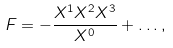Convert formula to latex. <formula><loc_0><loc_0><loc_500><loc_500>F = - \frac { X ^ { 1 } X ^ { 2 } X ^ { 3 } } { X ^ { 0 } } + \dots ,</formula> 